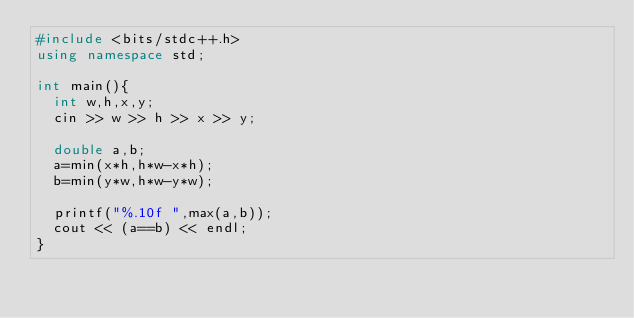<code> <loc_0><loc_0><loc_500><loc_500><_C++_>#include <bits/stdc++.h>
using namespace std;

int main(){
  int w,h,x,y;
  cin >> w >> h >> x >> y;
  
  double a,b;
  a=min(x*h,h*w-x*h);
  b=min(y*w,h*w-y*w);
  
  printf("%.10f ",max(a,b));
  cout << (a==b) << endl;
}</code> 